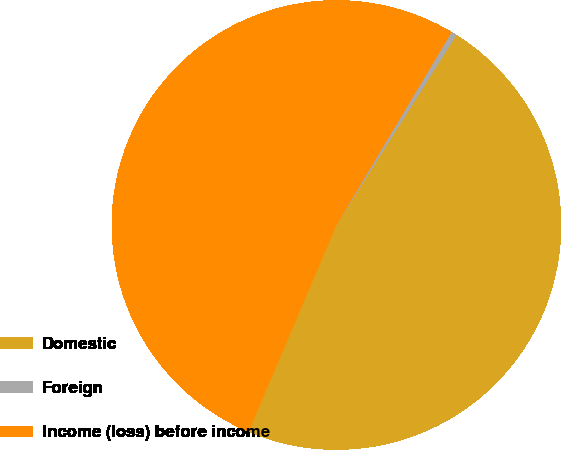<chart> <loc_0><loc_0><loc_500><loc_500><pie_chart><fcel>Domestic<fcel>Foreign<fcel>Income (loss) before income<nl><fcel>47.43%<fcel>0.4%<fcel>52.17%<nl></chart> 